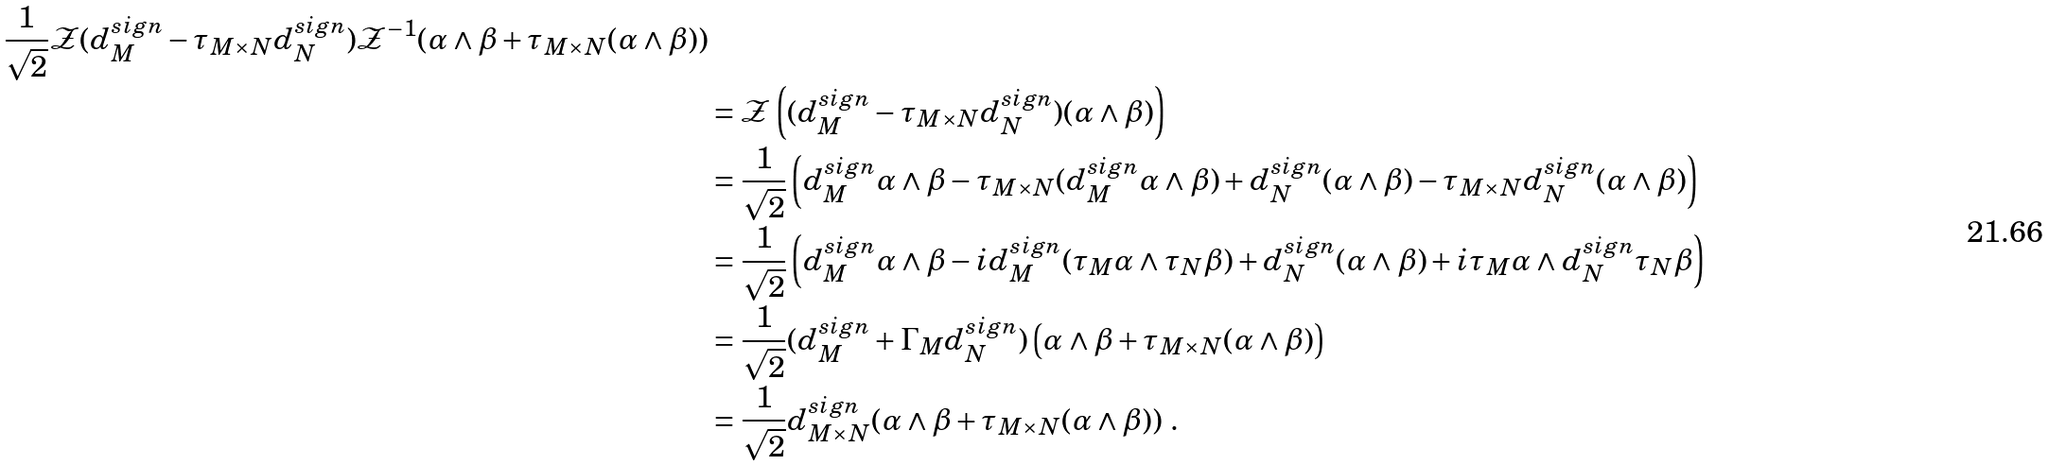Convert formula to latex. <formula><loc_0><loc_0><loc_500><loc_500>{ \frac { 1 } { \sqrt { 2 } } { \mathcal { Z } } ( d ^ { s i g n } _ { M } - \tau _ { M \times N } d _ { N } ^ { s i g n } ) { \mathcal { Z } } ^ { - 1 } ( \alpha \wedge \beta + \tau _ { M \times N } ( \alpha \wedge \beta ) ) } \\ & = { \mathcal { Z } } \left ( ( d ^ { s i g n } _ { M } - \tau _ { M \times N } d _ { N } ^ { s i g n } ) ( \alpha \wedge \beta ) \right ) \\ & = \frac { 1 } { \sqrt { 2 } } \left ( d ^ { s i g n } _ { M } \alpha \wedge \beta - \tau _ { M \times N } ( d _ { M } ^ { s i g n } \alpha \wedge \beta ) + d _ { N } ^ { s i g n } ( \alpha \wedge \beta ) - \tau _ { M \times N } d _ { N } ^ { s i g n } ( \alpha \wedge \beta ) \right ) \\ & = \frac { 1 } { \sqrt { 2 } } \left ( d ^ { s i g n } _ { M } \alpha \wedge \beta - i d _ { M } ^ { s i g n } ( \tau _ { M } \alpha \wedge \tau _ { N } \beta ) + d _ { N } ^ { s i g n } ( \alpha \wedge \beta ) + i \tau _ { M } \alpha \wedge d _ { N } ^ { s i g n } \tau _ { N } \beta \right ) \\ & = \frac { 1 } { \sqrt { 2 } } ( d _ { M } ^ { s i g n } + \Gamma _ { M } d _ { N } ^ { s i g n } ) \left ( \alpha \wedge \beta + \tau _ { M \times N } ( \alpha \wedge \beta ) \right ) \\ & = \frac { 1 } { \sqrt { 2 } } d _ { M \times N } ^ { s i g n } ( \alpha \wedge \beta + \tau _ { M \times N } ( \alpha \wedge \beta ) ) \ .</formula> 